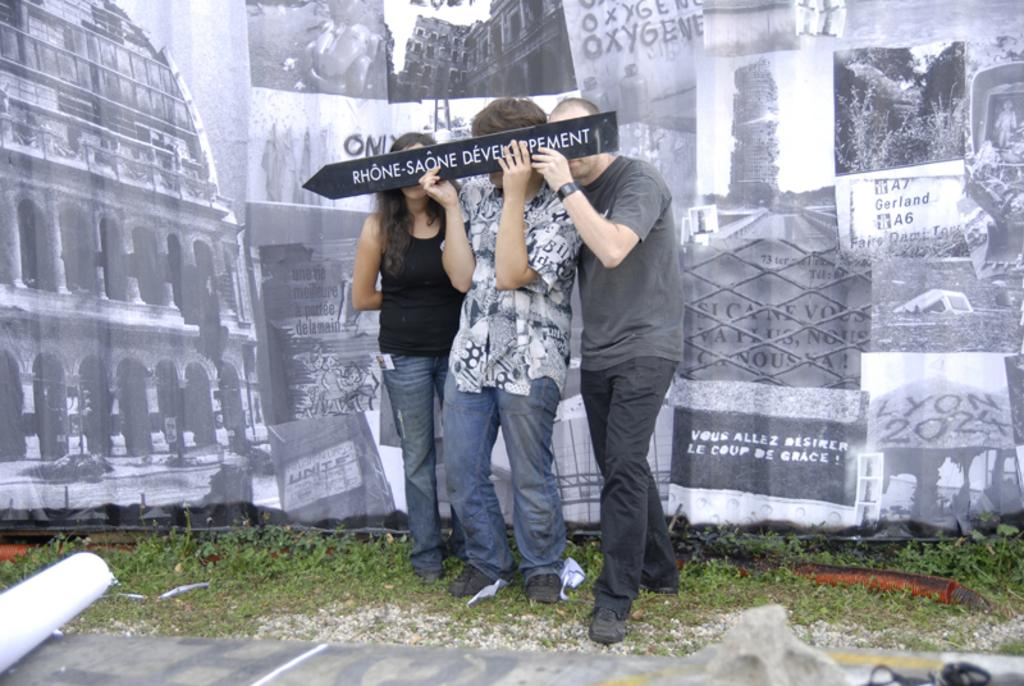How many people are present in the image? There are three people standing on the ground in the image. What are two of the people doing? Two of the people are holding a signboard. What type of surface is visible under the people's feet? There is grass visible in the image. What can be seen in the background of the image? There is a wall in the image. What type of milk is being poured on the signboard in the image? There is no milk present in the image, and the signboard is not being interacted with in any way that would involve pouring milk on it. 